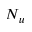<formula> <loc_0><loc_0><loc_500><loc_500>N _ { u }</formula> 